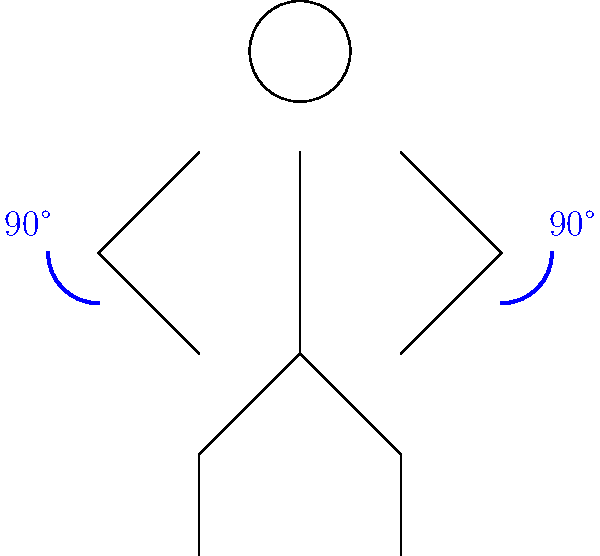In pose estimation for a bicep curl exercise, what is the ideal elbow angle at the top of the movement, as shown in the diagram? To determine the ideal elbow angle for a bicep curl at the top of the movement:

1. Analyze the stick figure diagram, which represents a person performing a bicep curl.
2. Notice the blue angle indicators at both elbows.
3. The angle indicators show a right angle (90°) at each elbow.
4. In a proper bicep curl, the goal is to fully contract the bicep muscle.
5. Full contraction occurs when the forearm is brought as close to the upper arm as possible.
6. This position is achieved when the elbow angle reaches approximately 90°.
7. The diagram clearly labels both elbow angles as 90°.

Therefore, the ideal elbow angle at the top of a bicep curl movement, as shown in the diagram, is 90°.
Answer: 90° 